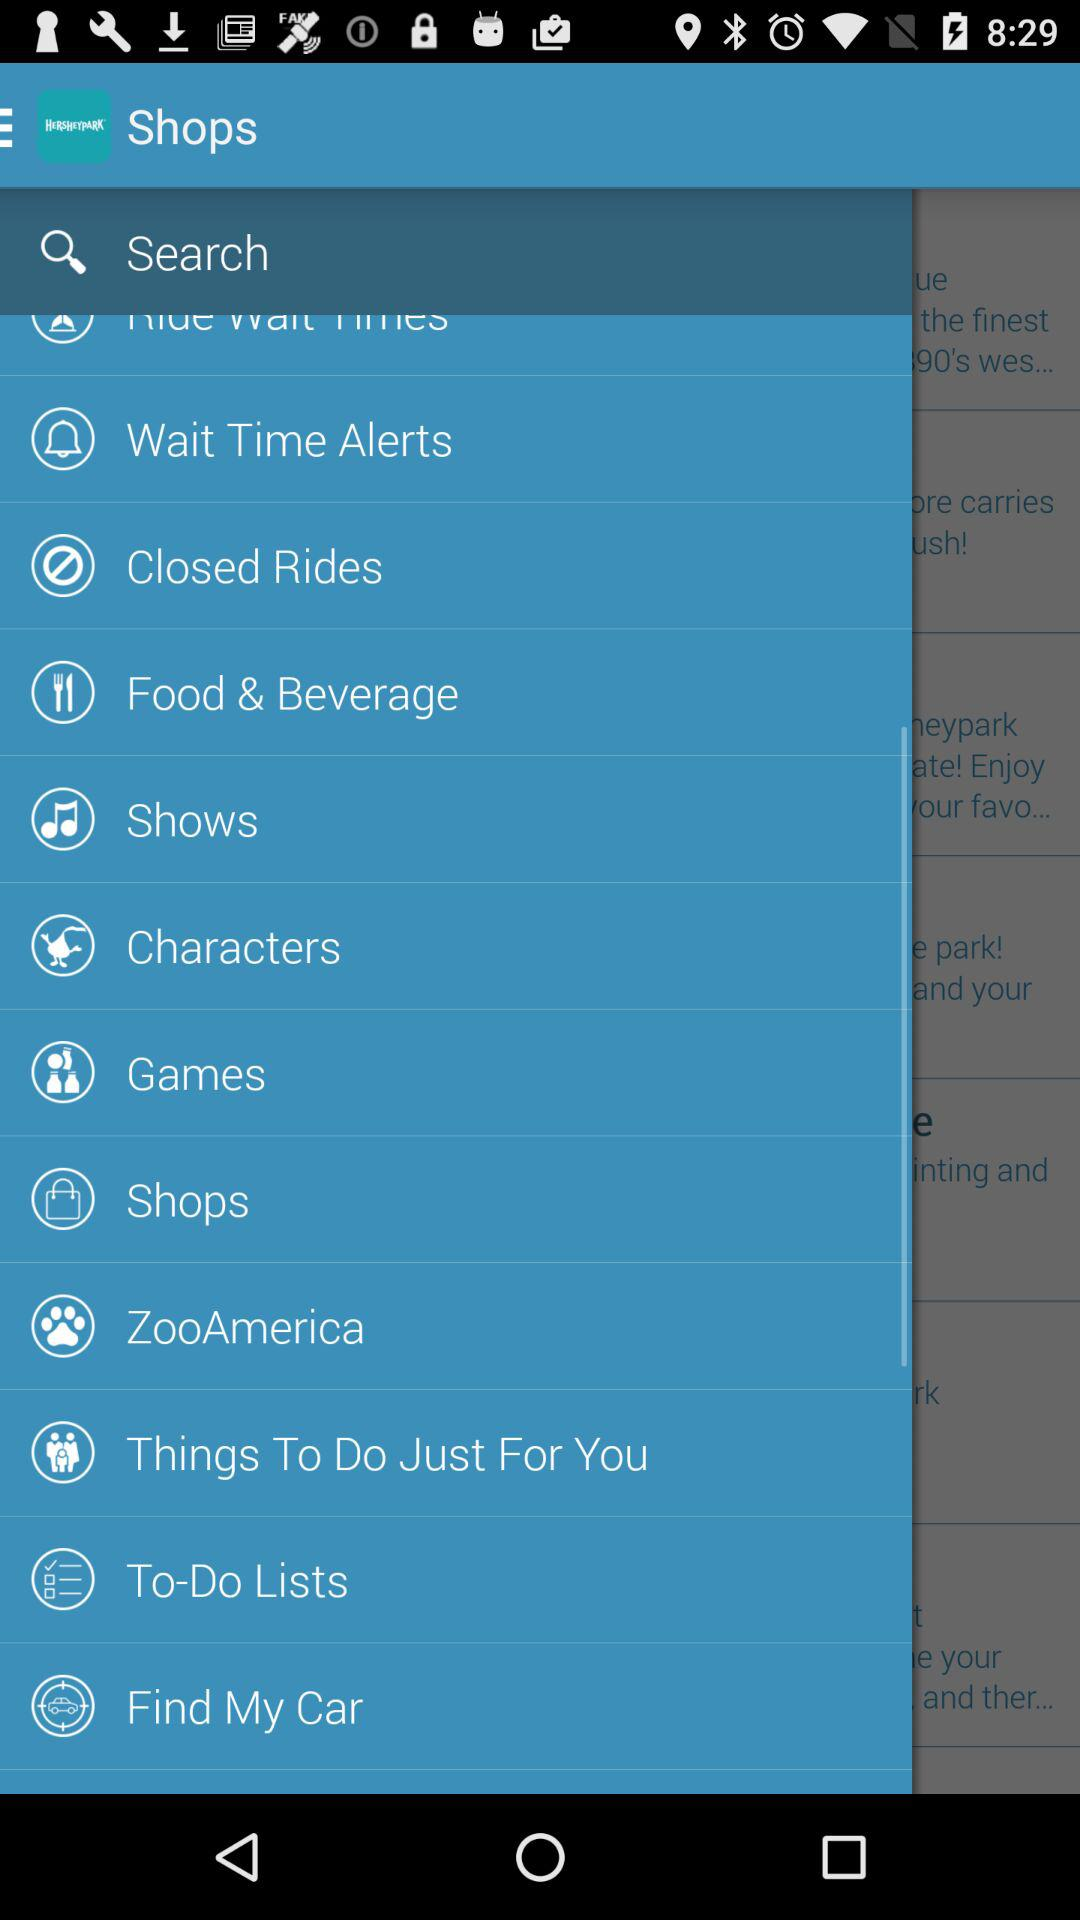What is the app name? The app name is "HERSHEYPARK". 